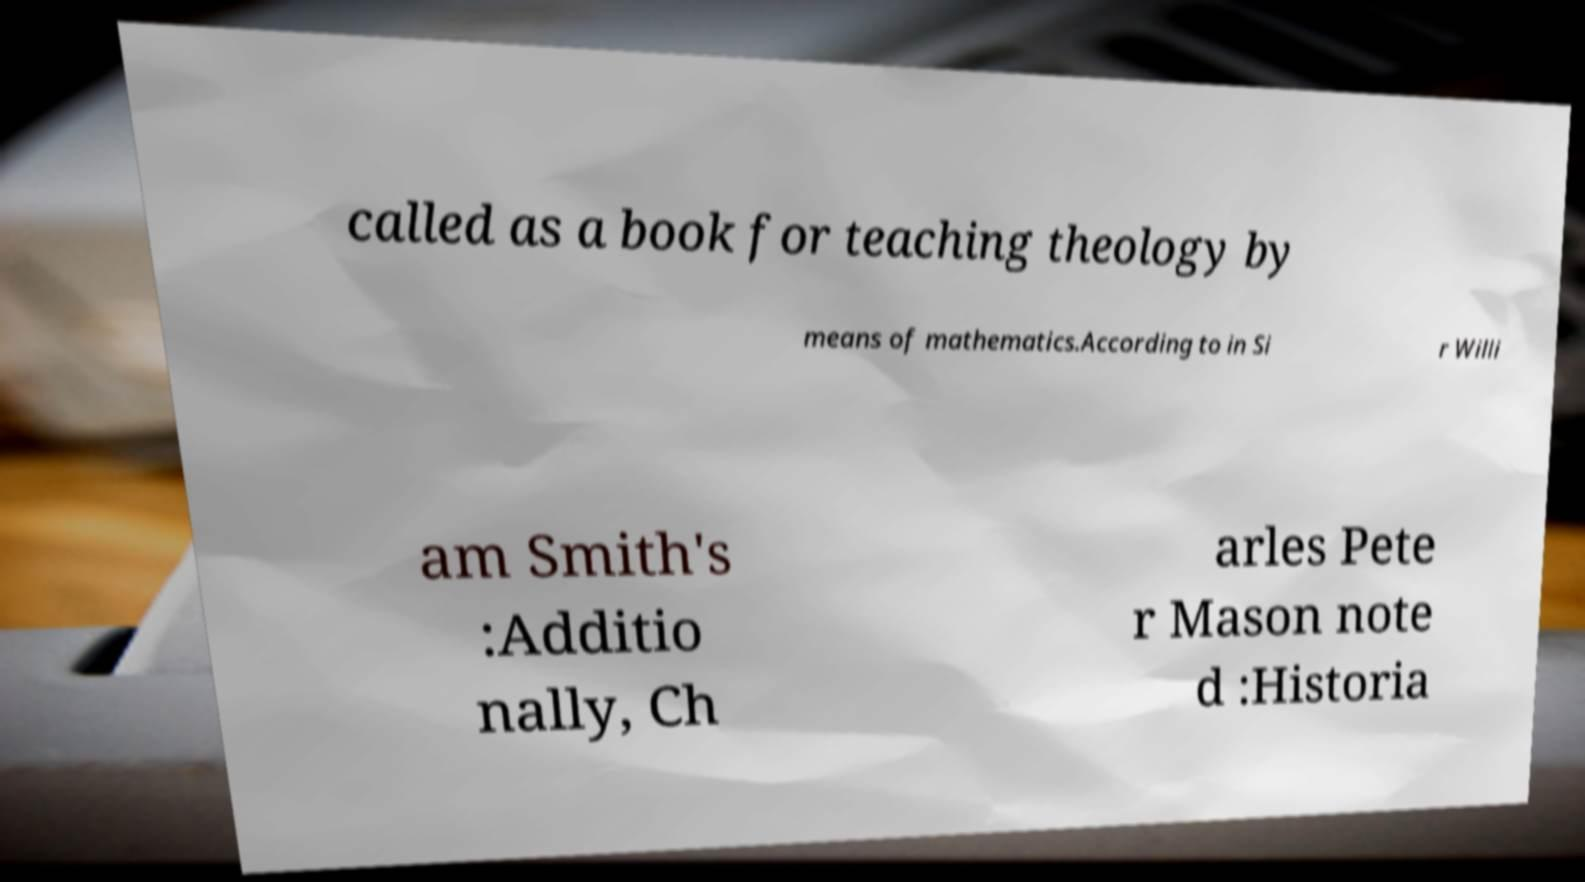Could you assist in decoding the text presented in this image and type it out clearly? called as a book for teaching theology by means of mathematics.According to in Si r Willi am Smith's :Additio nally, Ch arles Pete r Mason note d :Historia 